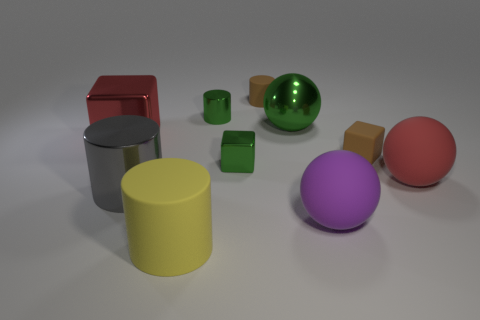Subtract all yellow cylinders. How many cylinders are left? 3 Subtract all tiny matte cylinders. How many cylinders are left? 3 Subtract all cyan cylinders. Subtract all red blocks. How many cylinders are left? 4 Subtract all cubes. How many objects are left? 7 Add 3 big red balls. How many big red balls are left? 4 Add 10 large yellow metallic balls. How many large yellow metallic balls exist? 10 Subtract 1 green cylinders. How many objects are left? 9 Subtract all big yellow cylinders. Subtract all large purple rubber spheres. How many objects are left? 8 